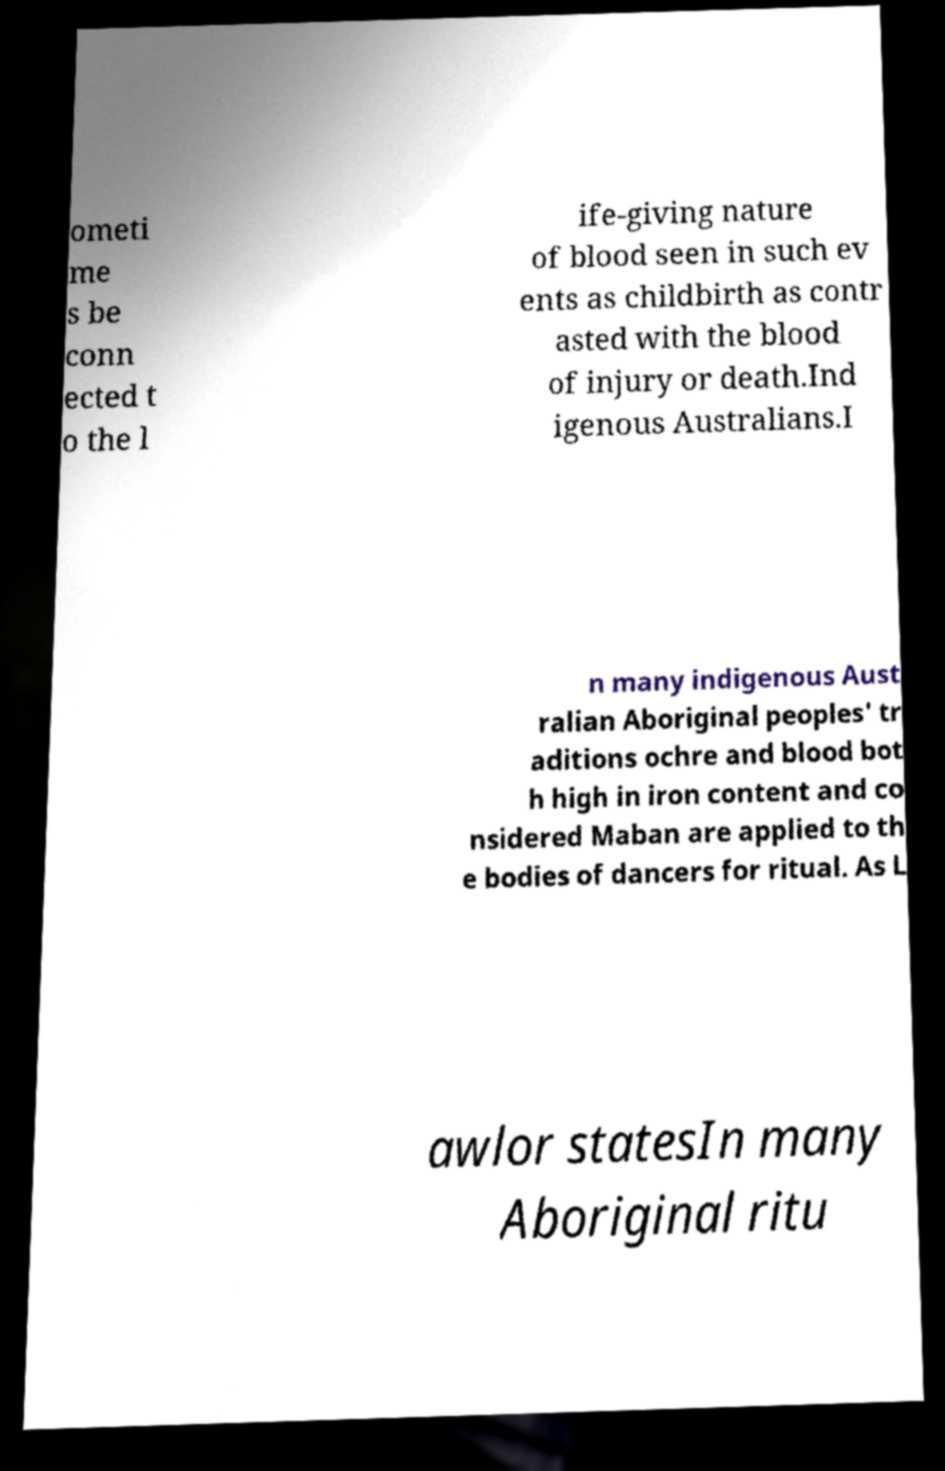I need the written content from this picture converted into text. Can you do that? ometi me s be conn ected t o the l ife-giving nature of blood seen in such ev ents as childbirth as contr asted with the blood of injury or death.Ind igenous Australians.I n many indigenous Aust ralian Aboriginal peoples' tr aditions ochre and blood bot h high in iron content and co nsidered Maban are applied to th e bodies of dancers for ritual. As L awlor statesIn many Aboriginal ritu 